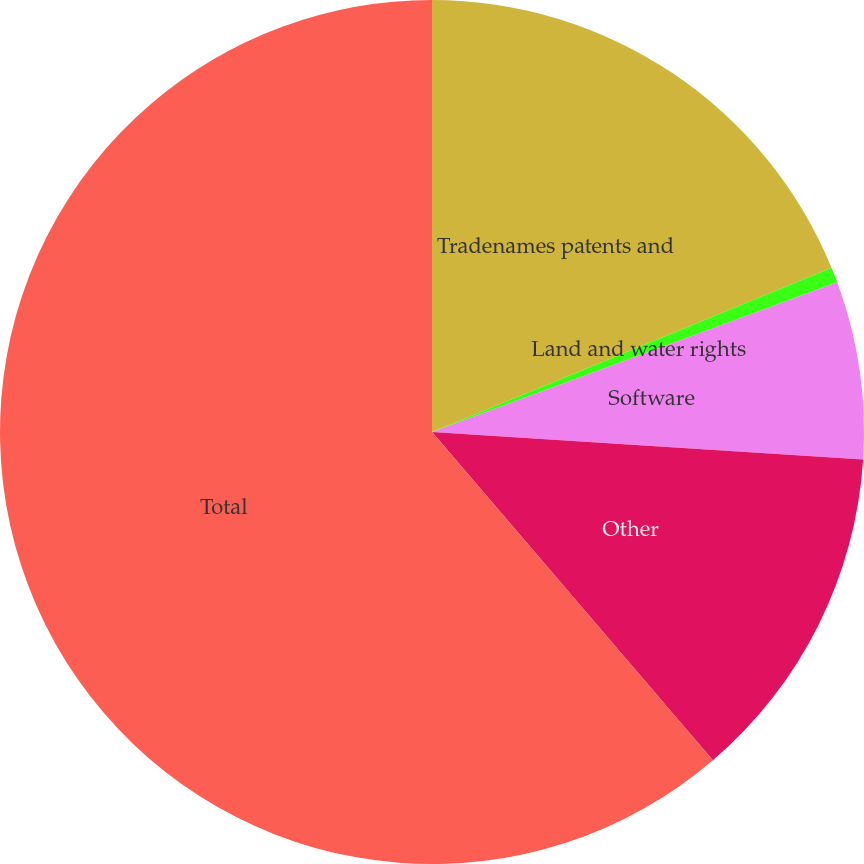Convert chart to OTSL. <chart><loc_0><loc_0><loc_500><loc_500><pie_chart><fcel>Tradenames patents and<fcel>Land and water rights<fcel>Software<fcel>Other<fcel>Total<nl><fcel>18.79%<fcel>0.58%<fcel>6.65%<fcel>12.72%<fcel>61.27%<nl></chart> 